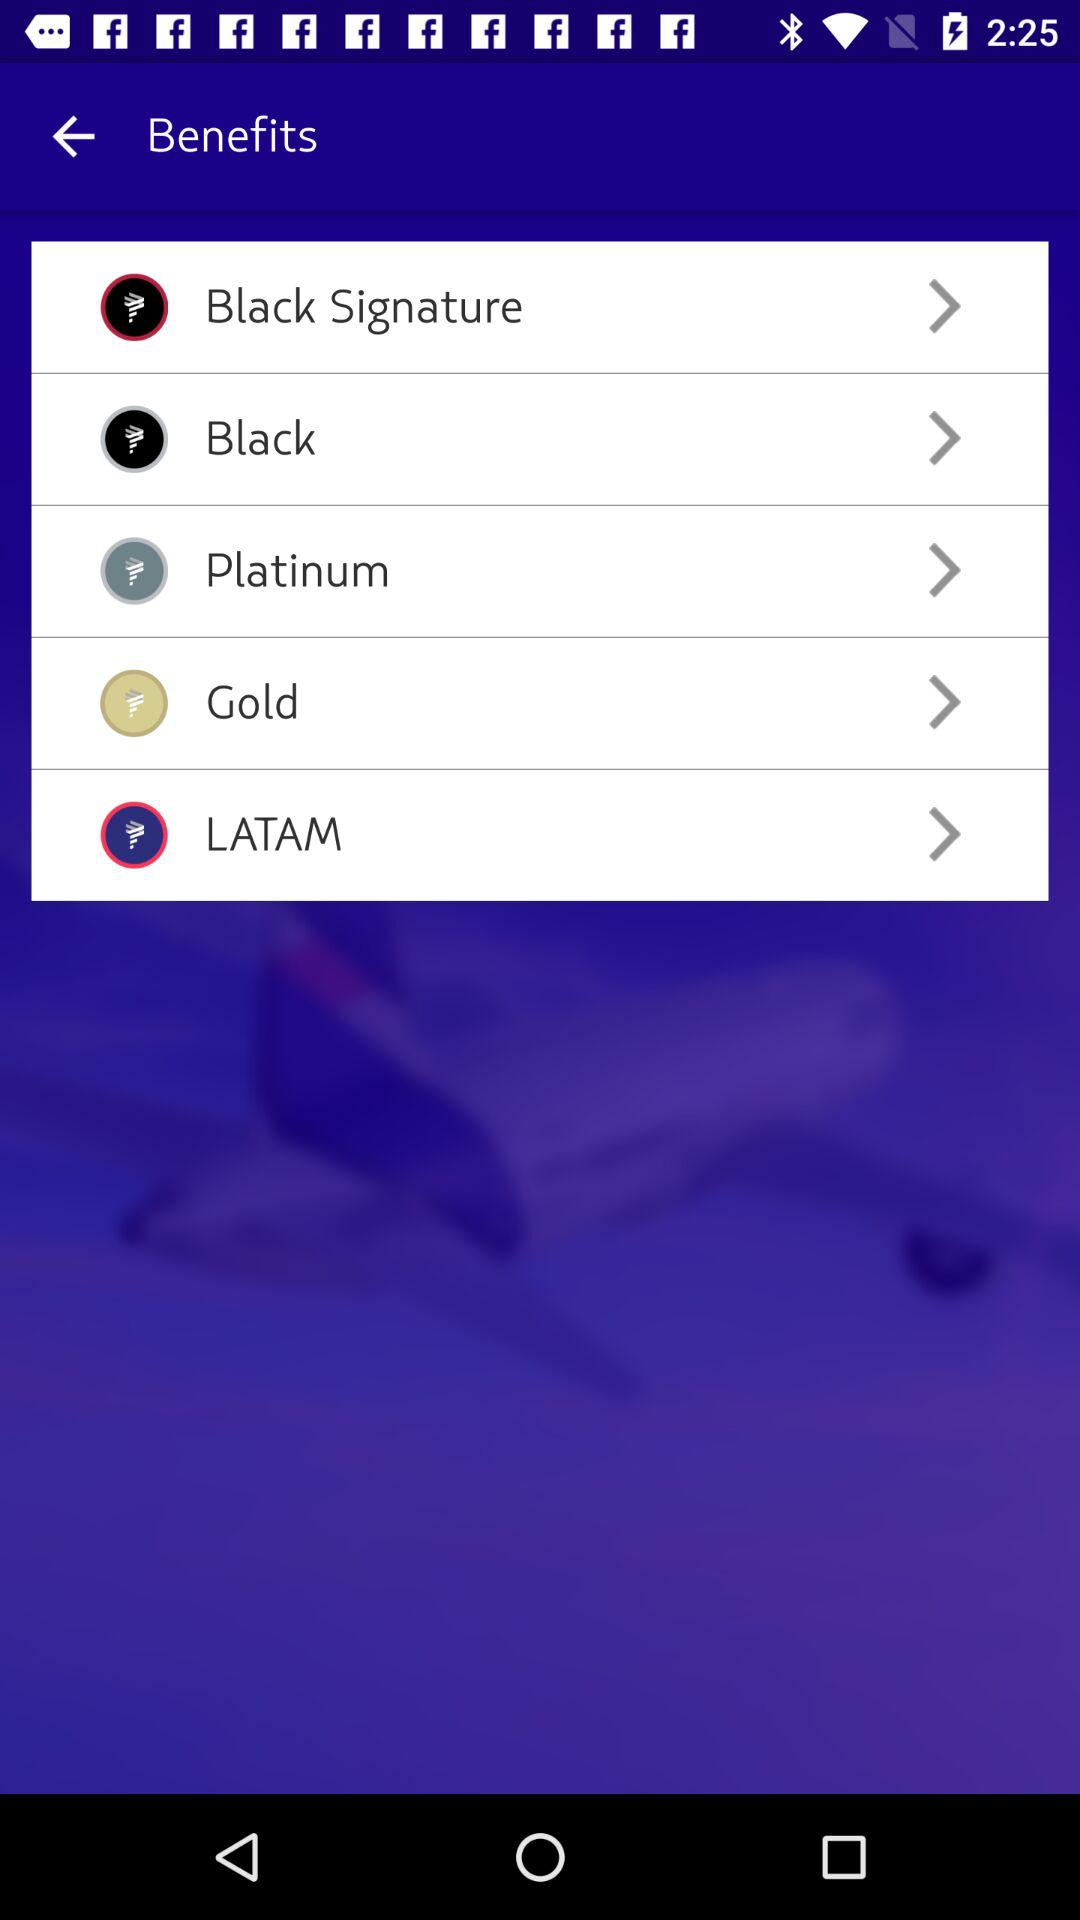How many benefits are there in total?
Answer the question using a single word or phrase. 5 